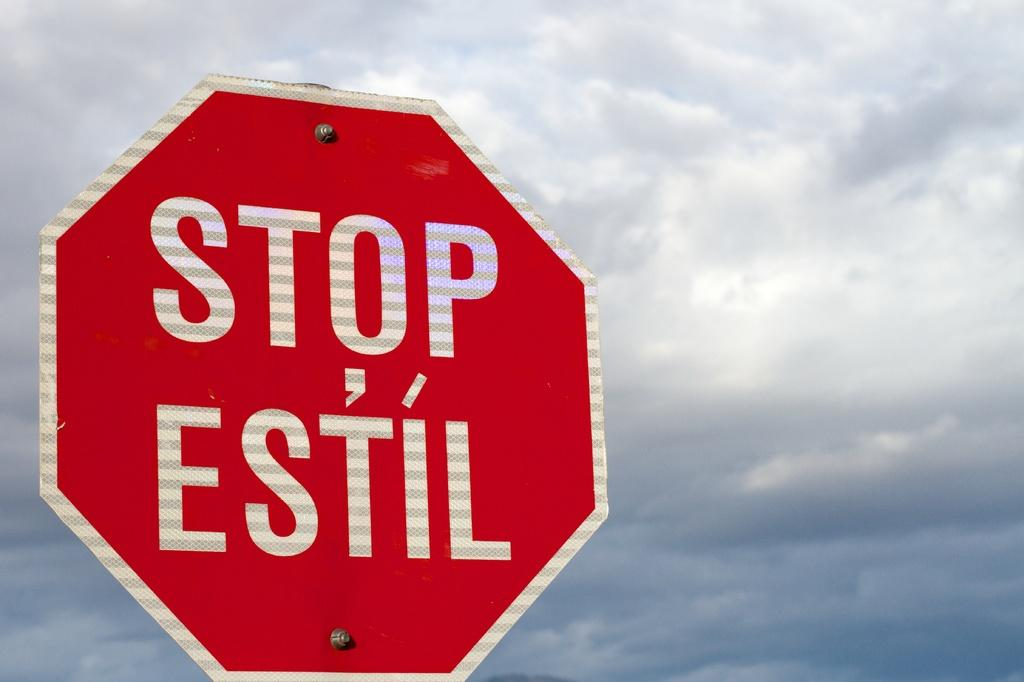<image>
Describe the image concisely. A read stop sign in English and Spanish. 